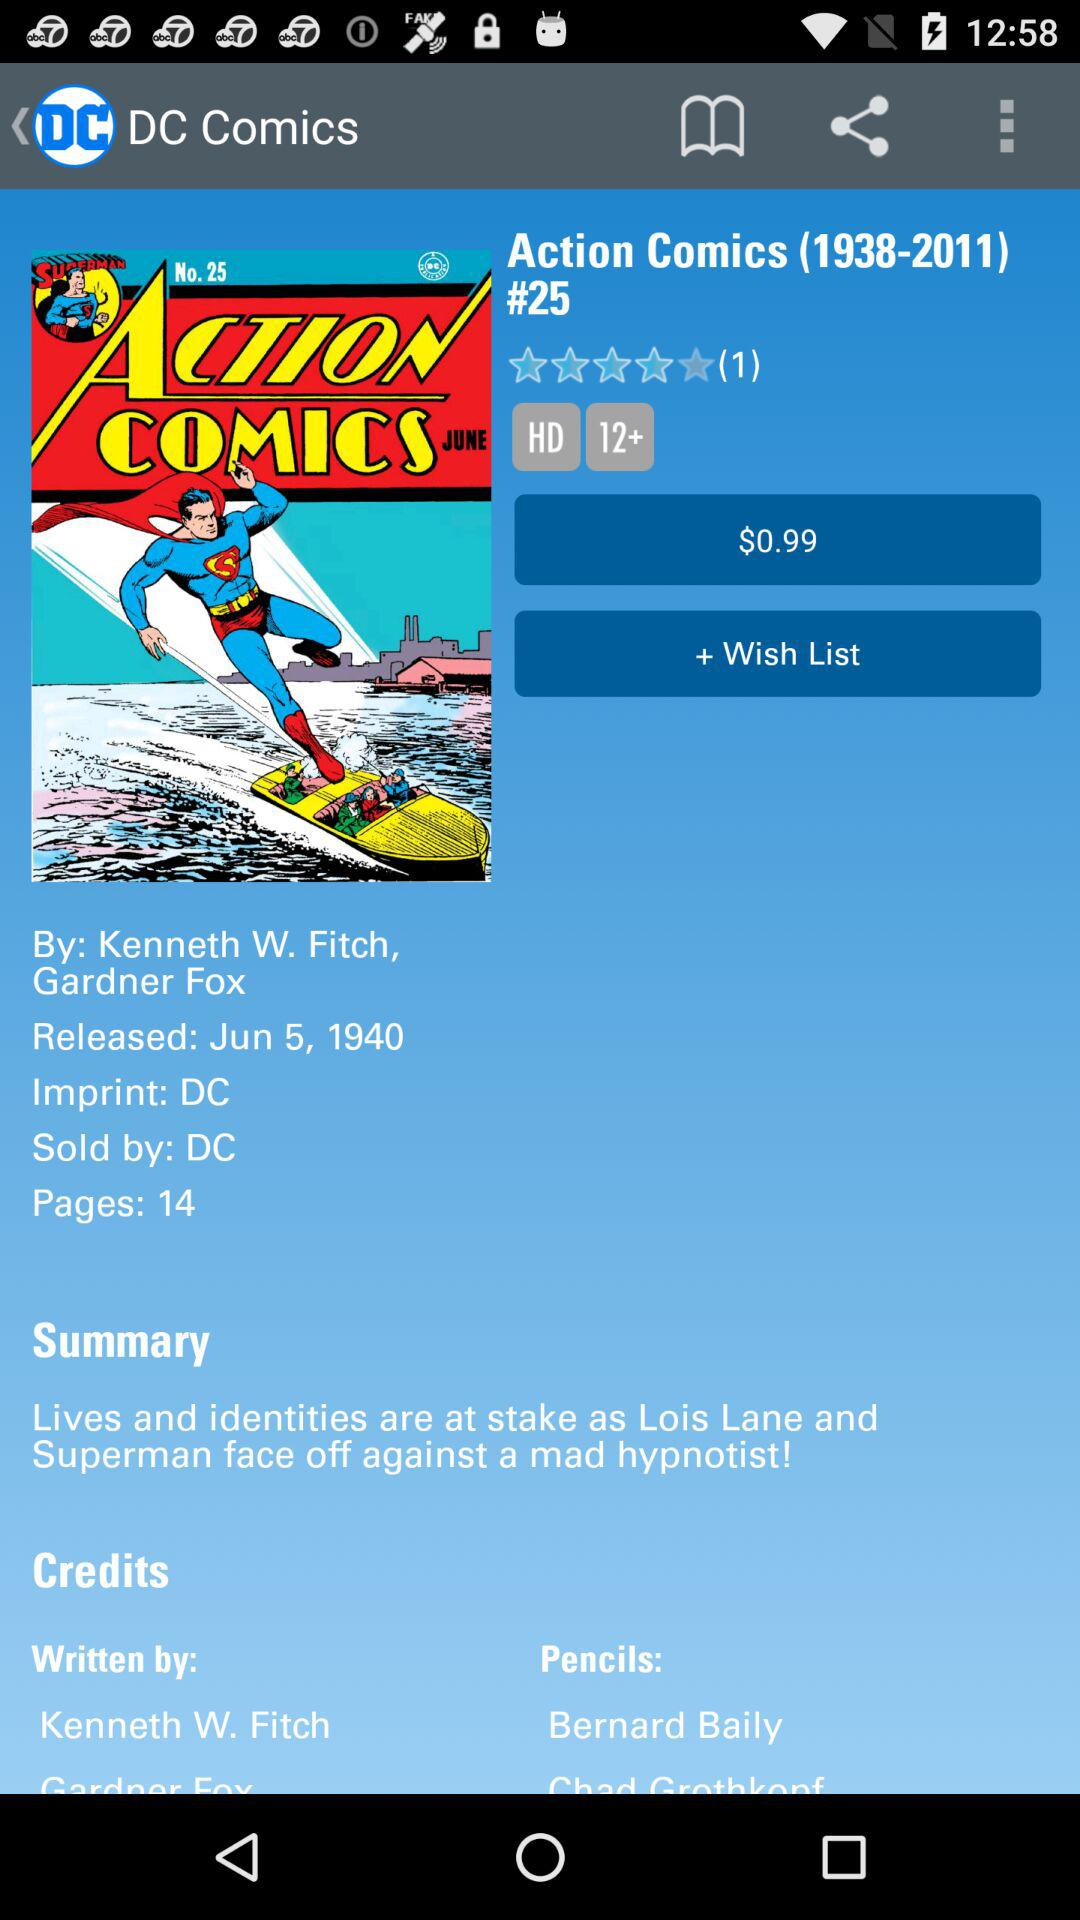By whom was the comic written? The comic was written by "Kenneth W. Fitch, Gardner Fox". 